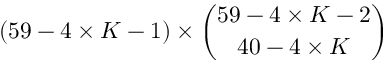<formula> <loc_0><loc_0><loc_500><loc_500>( 5 9 - 4 \times K - 1 ) \times \binom { 5 9 - 4 \times K - 2 } { 4 0 - 4 \times K }</formula> 